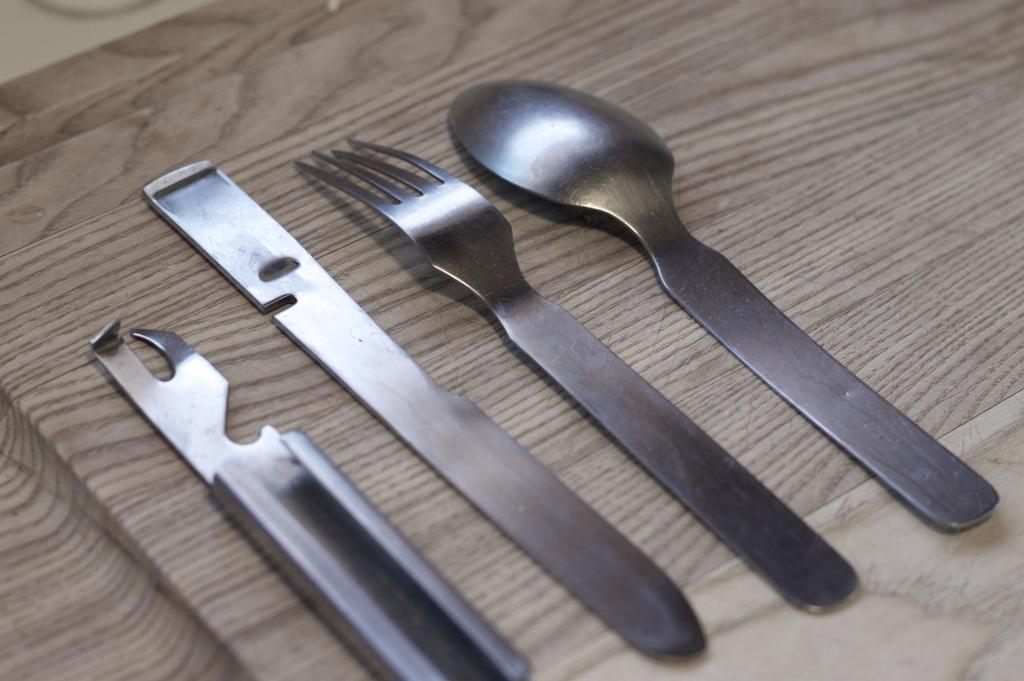What type of utensils can be seen in the image? There is a spoon, fork, and knife in the image. What other tool is present in the image? There is a cap opener in the image. On what surface are the utensils placed? A: The objects are placed on a wooden table. Reasoning: Let'g: Let's think step by step in order to produce the conversation. We start by identifying the main utensils in the image, which are the spoon, fork, and knife. Then, we mention the presence of the cap opener as an additional tool. Finally, we describe the surface on which the utensils are placed, which is a wooden table. Absurd Question/Answer: How many trees can be seen in the image? There are no trees visible in the image; it only shows utensils and a cap opener on a wooden table. What type of patch is being used by the farmer in the image? There is no farmer or patch present in the image. What type of patch is being used by the farmer in the image? There is no farmer or patch present in the image. 